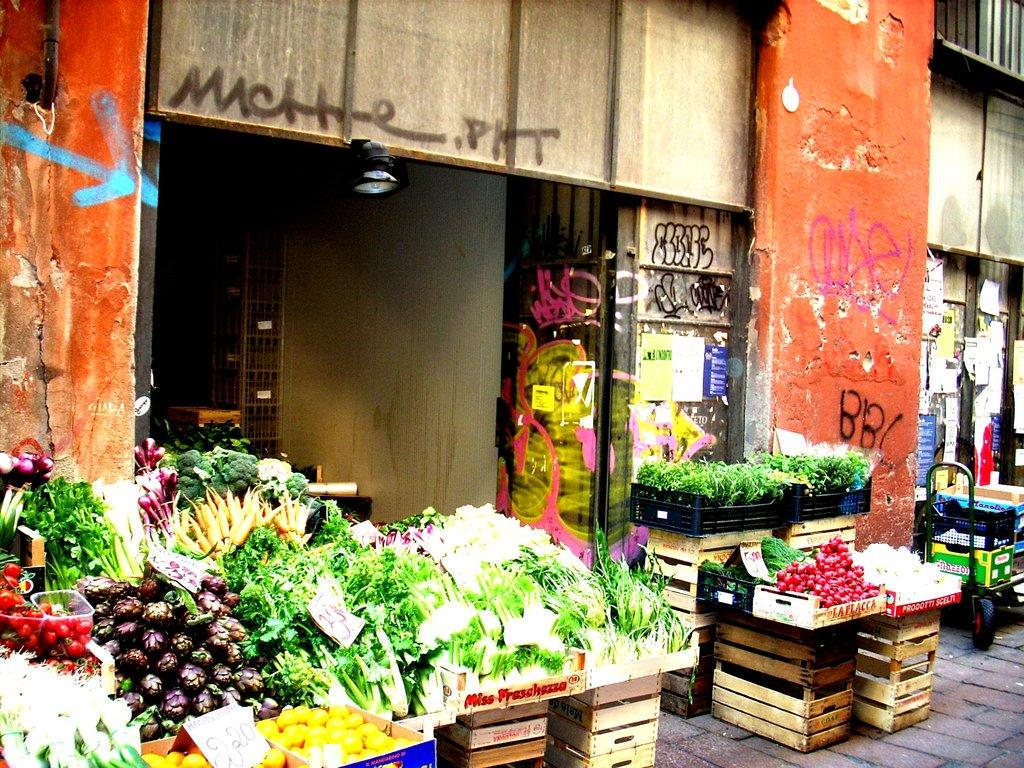What types of food are present in the image? There are various types of vegetables in the image. Where are the vegetables located? The vegetables are served on a table. What can be seen in the background of the image? There is a building in front of the table. What type of regret can be seen on the faces of the giants in the image? There are no giants present in the image, and therefore no regret can be observed on their faces. What is the kettle used for in the image? There is no kettle present in the image. 